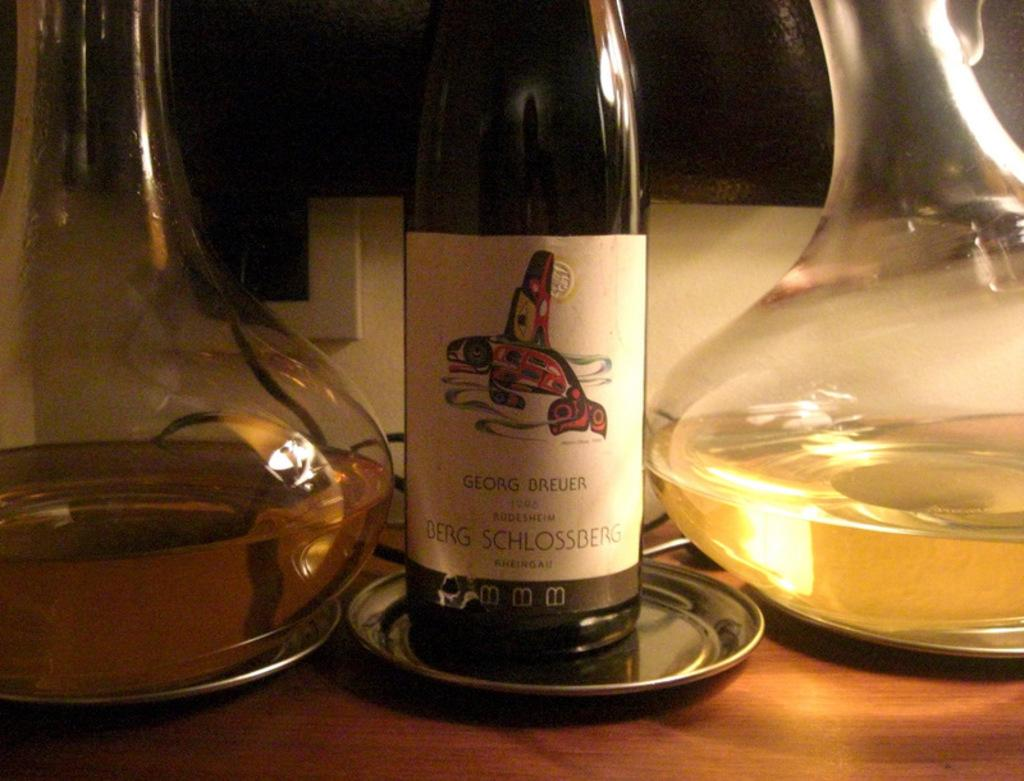<image>
Render a clear and concise summary of the photo. A bottle of Georg Breuer wine from 1996. 